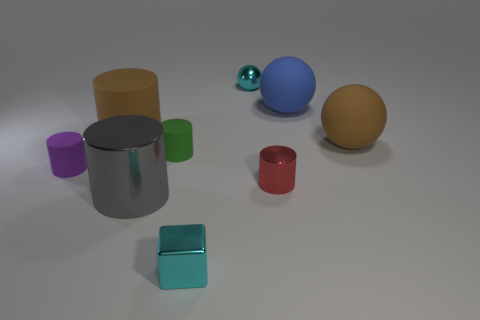Subtract 2 cylinders. How many cylinders are left? 3 Add 1 cyan spheres. How many objects exist? 10 Subtract all gray blocks. Subtract all red spheres. How many blocks are left? 1 Subtract all spheres. How many objects are left? 6 Subtract 0 green balls. How many objects are left? 9 Subtract all brown cylinders. Subtract all green things. How many objects are left? 7 Add 3 cubes. How many cubes are left? 4 Add 5 small blocks. How many small blocks exist? 6 